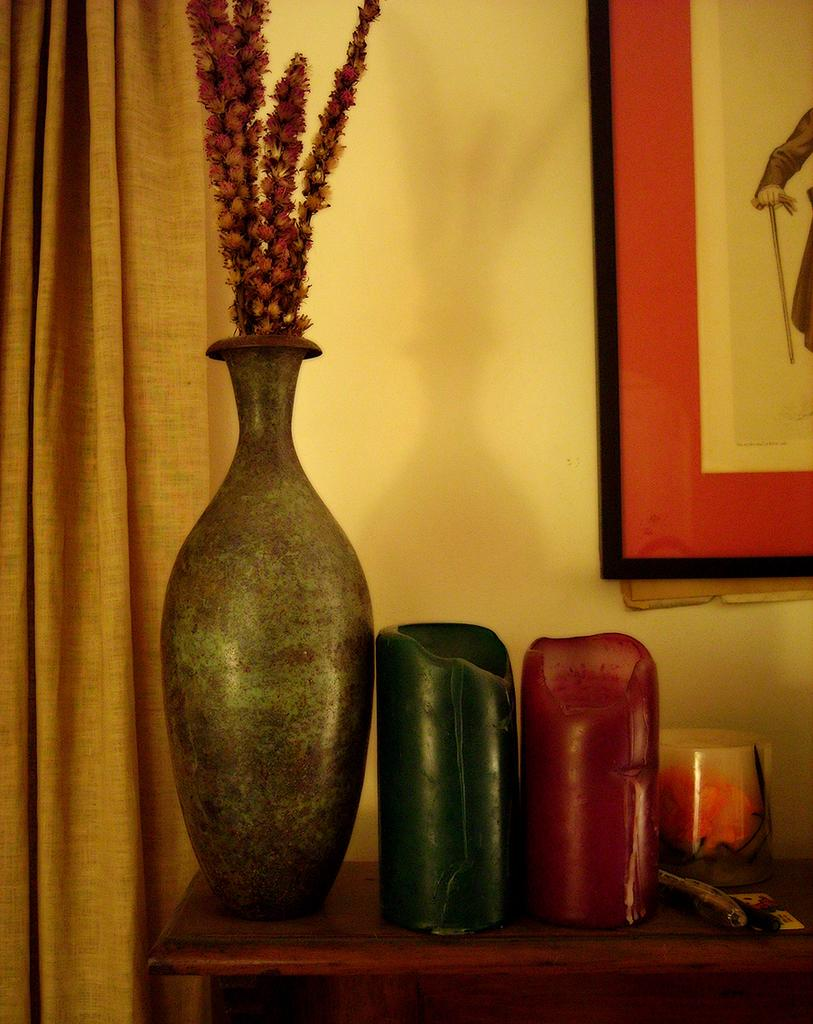What can be found in the image related to plants? There is a flower pot in the image. What is located on the table in the image? There are objects on the table in the image. What can be seen in the background of the image? There are curtains in the background of the image. What is hanging on the wall in the background? There is a photo frame on the wall in the background. How many rabbits are jumping on the table in the image? There are no rabbits present in the image. What channel is the TV set to in the image? There is no TV present in the image. 